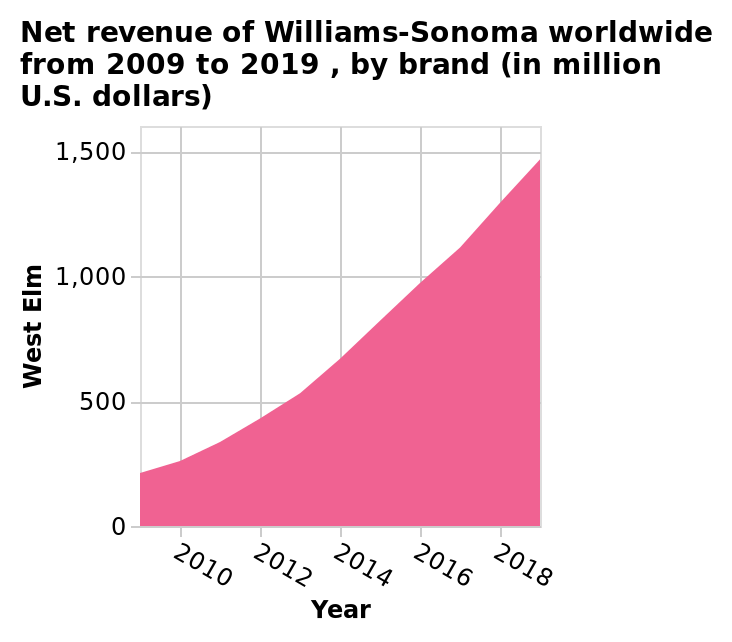<image>
How has West Elm's net revenue been changing over time?  West Elm's net revenue has been gradually increasing year after year. please summary the statistics and relations of the chart The net revenue of Williams-Sonoma worldwide from 2009 to 2019 has been growing fast and steadily. Offer a thorough analysis of the image. The net revenue of West Elm has been slowly and steadily rising each year. What is the name of the area diagram?  The area diagram is called Net revenue of Williams-Sonoma worldwide. 